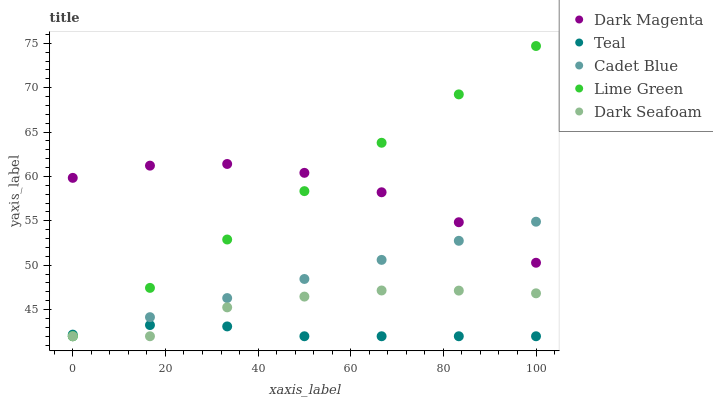Does Teal have the minimum area under the curve?
Answer yes or no. Yes. Does Dark Magenta have the maximum area under the curve?
Answer yes or no. Yes. Does Cadet Blue have the minimum area under the curve?
Answer yes or no. No. Does Cadet Blue have the maximum area under the curve?
Answer yes or no. No. Is Cadet Blue the smoothest?
Answer yes or no. Yes. Is Dark Seafoam the roughest?
Answer yes or no. Yes. Is Lime Green the smoothest?
Answer yes or no. No. Is Lime Green the roughest?
Answer yes or no. No. Does Dark Seafoam have the lowest value?
Answer yes or no. Yes. Does Dark Magenta have the lowest value?
Answer yes or no. No. Does Lime Green have the highest value?
Answer yes or no. Yes. Does Cadet Blue have the highest value?
Answer yes or no. No. Is Teal less than Dark Magenta?
Answer yes or no. Yes. Is Dark Magenta greater than Dark Seafoam?
Answer yes or no. Yes. Does Cadet Blue intersect Dark Seafoam?
Answer yes or no. Yes. Is Cadet Blue less than Dark Seafoam?
Answer yes or no. No. Is Cadet Blue greater than Dark Seafoam?
Answer yes or no. No. Does Teal intersect Dark Magenta?
Answer yes or no. No. 